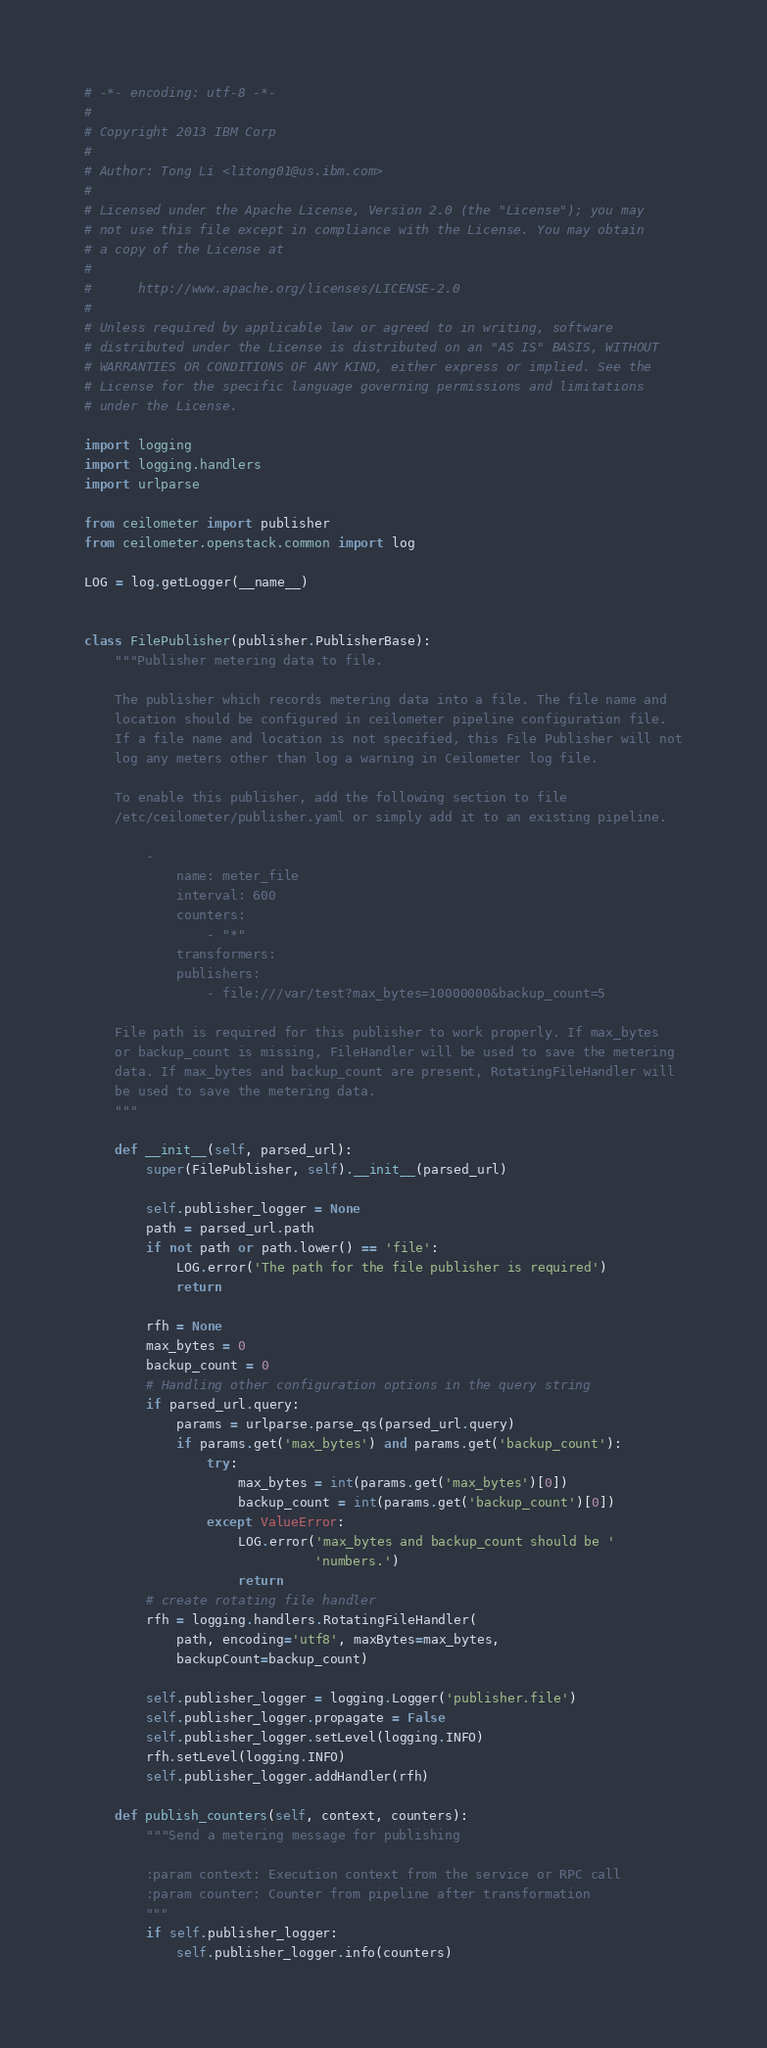<code> <loc_0><loc_0><loc_500><loc_500><_Python_># -*- encoding: utf-8 -*-
#
# Copyright 2013 IBM Corp
#
# Author: Tong Li <litong01@us.ibm.com>
#
# Licensed under the Apache License, Version 2.0 (the "License"); you may
# not use this file except in compliance with the License. You may obtain
# a copy of the License at
#
#      http://www.apache.org/licenses/LICENSE-2.0
#
# Unless required by applicable law or agreed to in writing, software
# distributed under the License is distributed on an "AS IS" BASIS, WITHOUT
# WARRANTIES OR CONDITIONS OF ANY KIND, either express or implied. See the
# License for the specific language governing permissions and limitations
# under the License.

import logging
import logging.handlers
import urlparse

from ceilometer import publisher
from ceilometer.openstack.common import log

LOG = log.getLogger(__name__)


class FilePublisher(publisher.PublisherBase):
    """Publisher metering data to file.

    The publisher which records metering data into a file. The file name and
    location should be configured in ceilometer pipeline configuration file.
    If a file name and location is not specified, this File Publisher will not
    log any meters other than log a warning in Ceilometer log file.

    To enable this publisher, add the following section to file
    /etc/ceilometer/publisher.yaml or simply add it to an existing pipeline.

        -
            name: meter_file
            interval: 600
            counters:
                - "*"
            transformers:
            publishers:
                - file:///var/test?max_bytes=10000000&backup_count=5

    File path is required for this publisher to work properly. If max_bytes
    or backup_count is missing, FileHandler will be used to save the metering
    data. If max_bytes and backup_count are present, RotatingFileHandler will
    be used to save the metering data.
    """

    def __init__(self, parsed_url):
        super(FilePublisher, self).__init__(parsed_url)

        self.publisher_logger = None
        path = parsed_url.path
        if not path or path.lower() == 'file':
            LOG.error('The path for the file publisher is required')
            return

        rfh = None
        max_bytes = 0
        backup_count = 0
        # Handling other configuration options in the query string
        if parsed_url.query:
            params = urlparse.parse_qs(parsed_url.query)
            if params.get('max_bytes') and params.get('backup_count'):
                try:
                    max_bytes = int(params.get('max_bytes')[0])
                    backup_count = int(params.get('backup_count')[0])
                except ValueError:
                    LOG.error('max_bytes and backup_count should be '
                              'numbers.')
                    return
        # create rotating file handler
        rfh = logging.handlers.RotatingFileHandler(
            path, encoding='utf8', maxBytes=max_bytes,
            backupCount=backup_count)

        self.publisher_logger = logging.Logger('publisher.file')
        self.publisher_logger.propagate = False
        self.publisher_logger.setLevel(logging.INFO)
        rfh.setLevel(logging.INFO)
        self.publisher_logger.addHandler(rfh)

    def publish_counters(self, context, counters):
        """Send a metering message for publishing

        :param context: Execution context from the service or RPC call
        :param counter: Counter from pipeline after transformation
        """
        if self.publisher_logger:
            self.publisher_logger.info(counters)
</code> 